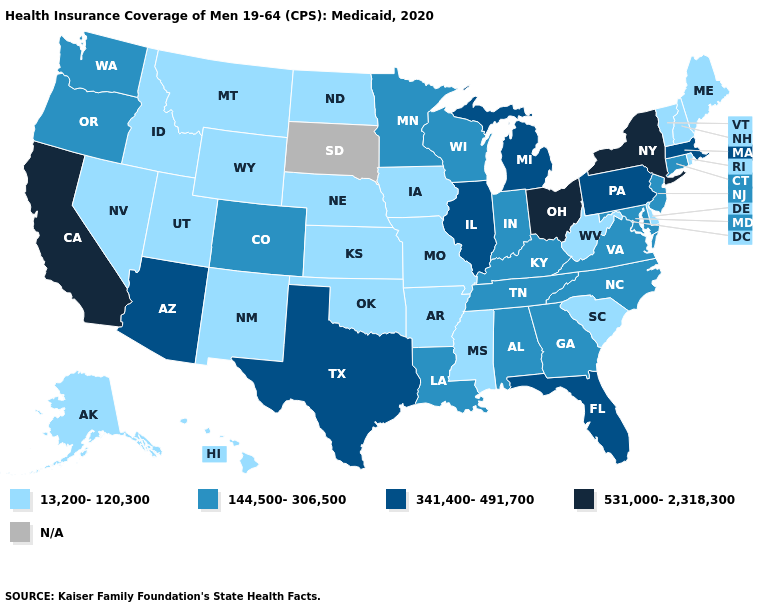What is the value of Illinois?
Give a very brief answer. 341,400-491,700. Does Wisconsin have the lowest value in the MidWest?
Short answer required. No. What is the value of Tennessee?
Concise answer only. 144,500-306,500. What is the highest value in the South ?
Concise answer only. 341,400-491,700. What is the lowest value in states that border Oklahoma?
Be succinct. 13,200-120,300. Name the states that have a value in the range 144,500-306,500?
Quick response, please. Alabama, Colorado, Connecticut, Georgia, Indiana, Kentucky, Louisiana, Maryland, Minnesota, New Jersey, North Carolina, Oregon, Tennessee, Virginia, Washington, Wisconsin. What is the value of Kentucky?
Write a very short answer. 144,500-306,500. What is the highest value in the West ?
Quick response, please. 531,000-2,318,300. What is the value of Alabama?
Answer briefly. 144,500-306,500. Does Missouri have the highest value in the MidWest?
Write a very short answer. No. Name the states that have a value in the range 13,200-120,300?
Answer briefly. Alaska, Arkansas, Delaware, Hawaii, Idaho, Iowa, Kansas, Maine, Mississippi, Missouri, Montana, Nebraska, Nevada, New Hampshire, New Mexico, North Dakota, Oklahoma, Rhode Island, South Carolina, Utah, Vermont, West Virginia, Wyoming. Which states have the lowest value in the West?
Write a very short answer. Alaska, Hawaii, Idaho, Montana, Nevada, New Mexico, Utah, Wyoming. Which states have the lowest value in the USA?
Be succinct. Alaska, Arkansas, Delaware, Hawaii, Idaho, Iowa, Kansas, Maine, Mississippi, Missouri, Montana, Nebraska, Nevada, New Hampshire, New Mexico, North Dakota, Oklahoma, Rhode Island, South Carolina, Utah, Vermont, West Virginia, Wyoming. What is the value of South Dakota?
Be succinct. N/A. What is the value of West Virginia?
Concise answer only. 13,200-120,300. 